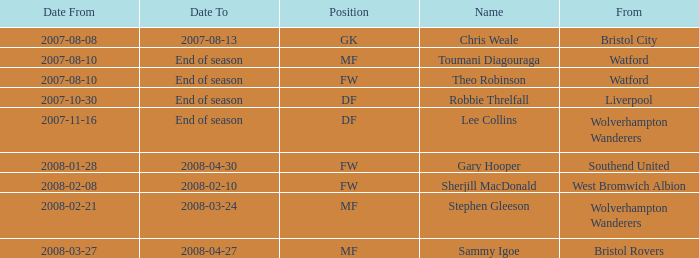How was the "date from" represented for 2007-08-08? Bristol City. 